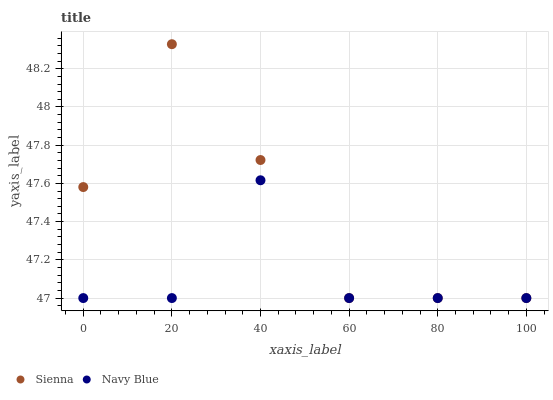Does Navy Blue have the minimum area under the curve?
Answer yes or no. Yes. Does Sienna have the maximum area under the curve?
Answer yes or no. Yes. Does Navy Blue have the maximum area under the curve?
Answer yes or no. No. Is Sienna the smoothest?
Answer yes or no. Yes. Is Navy Blue the roughest?
Answer yes or no. Yes. Is Navy Blue the smoothest?
Answer yes or no. No. Does Sienna have the lowest value?
Answer yes or no. Yes. Does Sienna have the highest value?
Answer yes or no. Yes. Does Navy Blue have the highest value?
Answer yes or no. No. Does Navy Blue intersect Sienna?
Answer yes or no. Yes. Is Navy Blue less than Sienna?
Answer yes or no. No. Is Navy Blue greater than Sienna?
Answer yes or no. No. 